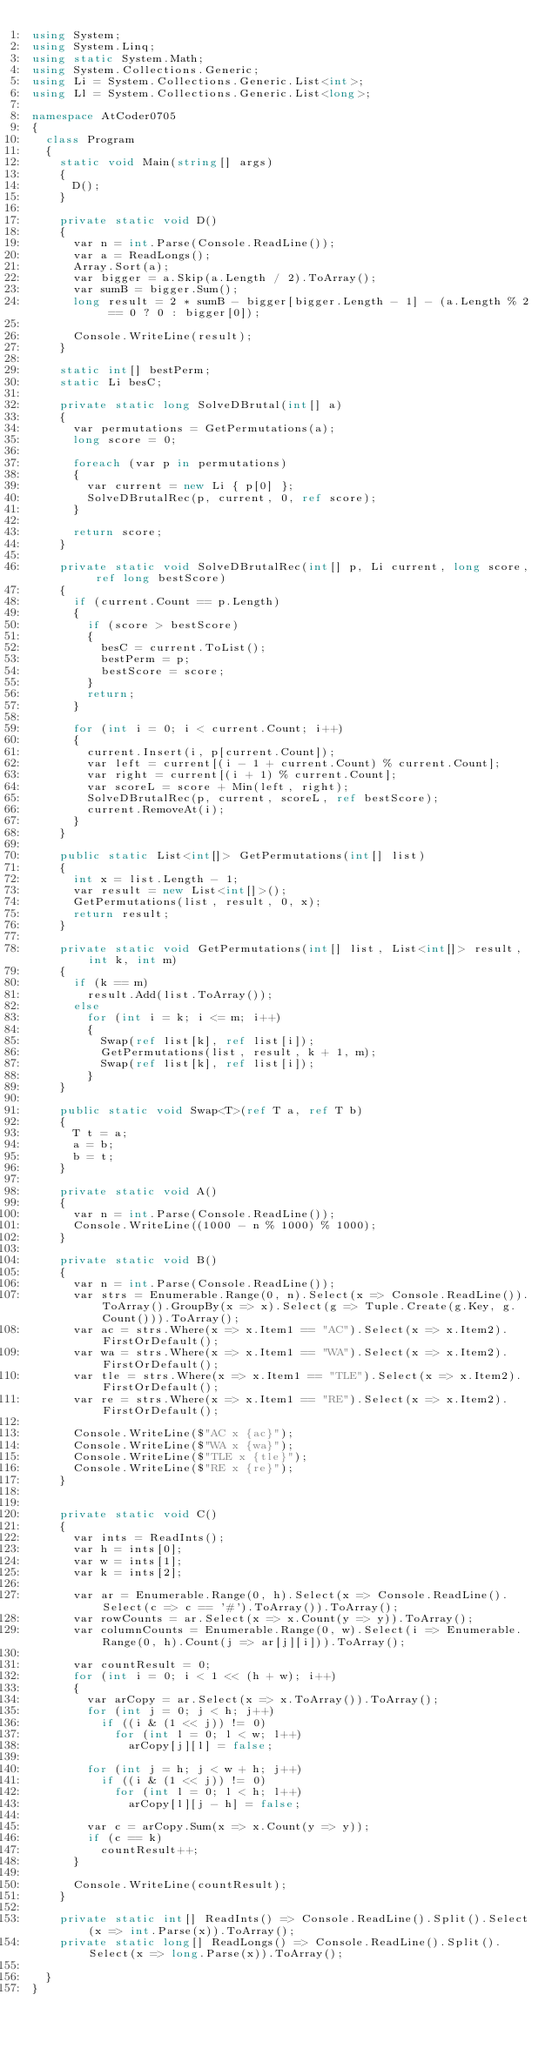<code> <loc_0><loc_0><loc_500><loc_500><_C#_>using System;
using System.Linq;
using static System.Math;
using System.Collections.Generic;
using Li = System.Collections.Generic.List<int>;
using Ll = System.Collections.Generic.List<long>;

namespace AtCoder0705
{
	class Program
	{
		static void Main(string[] args)
		{
			D();
		}

		private static void D()
		{
			var n = int.Parse(Console.ReadLine());
			var a = ReadLongs();
			Array.Sort(a);
			var bigger = a.Skip(a.Length / 2).ToArray();
			var sumB = bigger.Sum();
			long result = 2 * sumB - bigger[bigger.Length - 1] - (a.Length % 2 == 0 ? 0 : bigger[0]);

			Console.WriteLine(result);
		}

		static int[] bestPerm;
		static Li besC;

		private static long SolveDBrutal(int[] a)
		{
			var permutations = GetPermutations(a);
			long score = 0;

			foreach (var p in permutations)
			{
				var current = new Li { p[0] };
				SolveDBrutalRec(p, current, 0, ref score);
			}

			return score;
		}

		private static void SolveDBrutalRec(int[] p, Li current, long score, ref long bestScore)
		{
			if (current.Count == p.Length)
			{
				if (score > bestScore)
				{
					besC = current.ToList();
					bestPerm = p;
					bestScore = score;
				}
				return;
			}

			for (int i = 0; i < current.Count; i++)
			{
				current.Insert(i, p[current.Count]);
				var left = current[(i - 1 + current.Count) % current.Count];
				var right = current[(i + 1) % current.Count];
				var scoreL = score + Min(left, right);
				SolveDBrutalRec(p, current, scoreL, ref bestScore);
				current.RemoveAt(i);
			}
		}

		public static List<int[]> GetPermutations(int[] list)
		{
			int x = list.Length - 1;
			var result = new List<int[]>();
			GetPermutations(list, result, 0, x);
			return result;
		}

		private static void GetPermutations(int[] list, List<int[]> result, int k, int m)
		{
			if (k == m)
				result.Add(list.ToArray());
			else
				for (int i = k; i <= m; i++)
				{
					Swap(ref list[k], ref list[i]);
					GetPermutations(list, result, k + 1, m);
					Swap(ref list[k], ref list[i]);
				}
		}

		public static void Swap<T>(ref T a, ref T b)
		{
			T t = a;
			a = b;
			b = t;
		}

		private static void A()
		{
			var n = int.Parse(Console.ReadLine());
			Console.WriteLine((1000 - n % 1000) % 1000);
		}

		private static void B()
		{
			var n = int.Parse(Console.ReadLine());
			var strs = Enumerable.Range(0, n).Select(x => Console.ReadLine()).ToArray().GroupBy(x => x).Select(g => Tuple.Create(g.Key, g.Count())).ToArray();
			var ac = strs.Where(x => x.Item1 == "AC").Select(x => x.Item2).FirstOrDefault();
			var wa = strs.Where(x => x.Item1 == "WA").Select(x => x.Item2).FirstOrDefault();
			var tle = strs.Where(x => x.Item1 == "TLE").Select(x => x.Item2).FirstOrDefault();
			var re = strs.Where(x => x.Item1 == "RE").Select(x => x.Item2).FirstOrDefault();

			Console.WriteLine($"AC x {ac}");
			Console.WriteLine($"WA x {wa}");
			Console.WriteLine($"TLE x {tle}");
			Console.WriteLine($"RE x {re}");
		}


		private static void C()
		{
			var ints = ReadInts();
			var h = ints[0];
			var w = ints[1];
			var k = ints[2];

			var ar = Enumerable.Range(0, h).Select(x => Console.ReadLine().Select(c => c == '#').ToArray()).ToArray();
			var rowCounts = ar.Select(x => x.Count(y => y)).ToArray();
			var columnCounts = Enumerable.Range(0, w).Select(i => Enumerable.Range(0, h).Count(j => ar[j][i])).ToArray();

			var countResult = 0;
			for (int i = 0; i < 1 << (h + w); i++)
			{
				var arCopy = ar.Select(x => x.ToArray()).ToArray();
				for (int j = 0; j < h; j++)
					if ((i & (1 << j)) != 0)
						for (int l = 0; l < w; l++)
							arCopy[j][l] = false;

				for (int j = h; j < w + h; j++)
					if ((i & (1 << j)) != 0)
						for (int l = 0; l < h; l++)
							arCopy[l][j - h] = false;

				var c = arCopy.Sum(x => x.Count(y => y));
				if (c == k)
					countResult++;
			}

			Console.WriteLine(countResult);
		}

		private static int[] ReadInts() => Console.ReadLine().Split().Select(x => int.Parse(x)).ToArray();
		private static long[] ReadLongs() => Console.ReadLine().Split().Select(x => long.Parse(x)).ToArray();

	}
}
</code> 